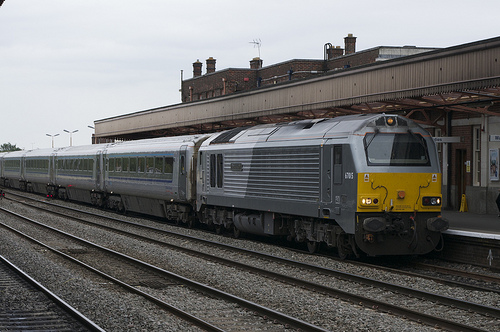Please provide the bounding box coordinate of the region this sentence describes: yellow and red train. [0.61, 0.38, 0.94, 0.67] Please provide the bounding box coordinate of the region this sentence describes: Small window on a train. [0.41, 0.46, 0.46, 0.56] Please provide a short description for this region: [0.0, 0.44, 0.38, 0.62]. Large grey train carts oin track. Please provide the bounding box coordinate of the region this sentence describes: a door on the train. [0.64, 0.48, 0.68, 0.56] Please provide the bounding box coordinate of the region this sentence describes: white clouds in blue sky. [0.24, 0.21, 0.33, 0.3] Please provide the bounding box coordinate of the region this sentence describes: side of the train. [0.34, 0.41, 0.72, 0.62] Please provide the bounding box coordinate of the region this sentence describes: white clouds in blue sky. [0.11, 0.3, 0.17, 0.34] Please provide the bounding box coordinate of the region this sentence describes: Small window on a train. [0.22, 0.47, 0.3, 0.51] Please provide a short description for this region: [0.04, 0.19, 0.07, 0.23]. White clouds in blue sky. Please provide a short description for this region: [0.07, 0.33, 0.13, 0.39]. White clouds in blue sky. 